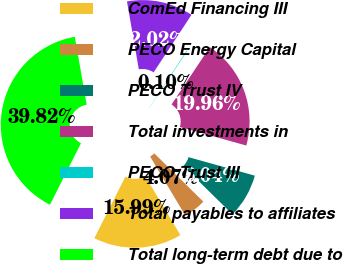Convert chart to OTSL. <chart><loc_0><loc_0><loc_500><loc_500><pie_chart><fcel>ComEd Financing III<fcel>PECO Energy Capital<fcel>PECO Trust IV<fcel>Total investments in<fcel>PECO Trust III<fcel>Total payables to affiliates<fcel>Total long-term debt due to<nl><fcel>15.99%<fcel>4.07%<fcel>8.04%<fcel>19.96%<fcel>0.1%<fcel>12.02%<fcel>39.82%<nl></chart> 